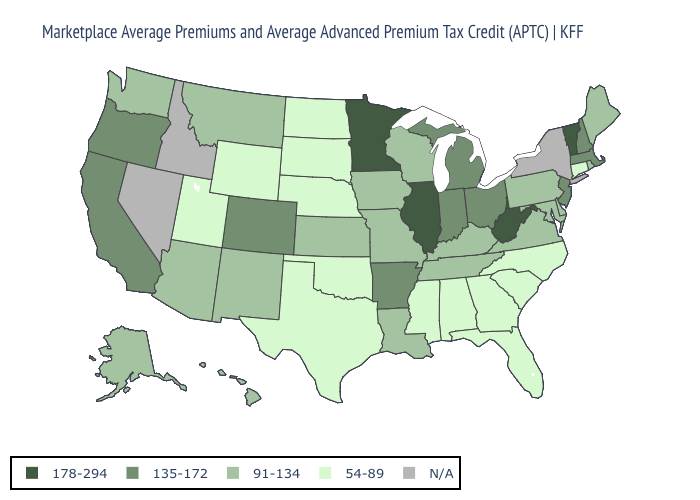What is the value of North Dakota?
Be succinct. 54-89. Which states hav the highest value in the MidWest?
Answer briefly. Illinois, Minnesota. Does Wyoming have the lowest value in the West?
Write a very short answer. Yes. Name the states that have a value in the range 178-294?
Give a very brief answer. Illinois, Minnesota, Vermont, West Virginia. Which states hav the highest value in the West?
Keep it brief. California, Colorado, Oregon. Is the legend a continuous bar?
Give a very brief answer. No. Name the states that have a value in the range 54-89?
Keep it brief. Alabama, Connecticut, Florida, Georgia, Mississippi, Nebraska, North Carolina, North Dakota, Oklahoma, South Carolina, South Dakota, Texas, Utah, Wyoming. Name the states that have a value in the range 54-89?
Concise answer only. Alabama, Connecticut, Florida, Georgia, Mississippi, Nebraska, North Carolina, North Dakota, Oklahoma, South Carolina, South Dakota, Texas, Utah, Wyoming. What is the highest value in the USA?
Write a very short answer. 178-294. Name the states that have a value in the range N/A?
Be succinct. Idaho, Nevada, New York. What is the value of South Dakota?
Concise answer only. 54-89. What is the value of North Dakota?
Answer briefly. 54-89. What is the highest value in the USA?
Give a very brief answer. 178-294. 